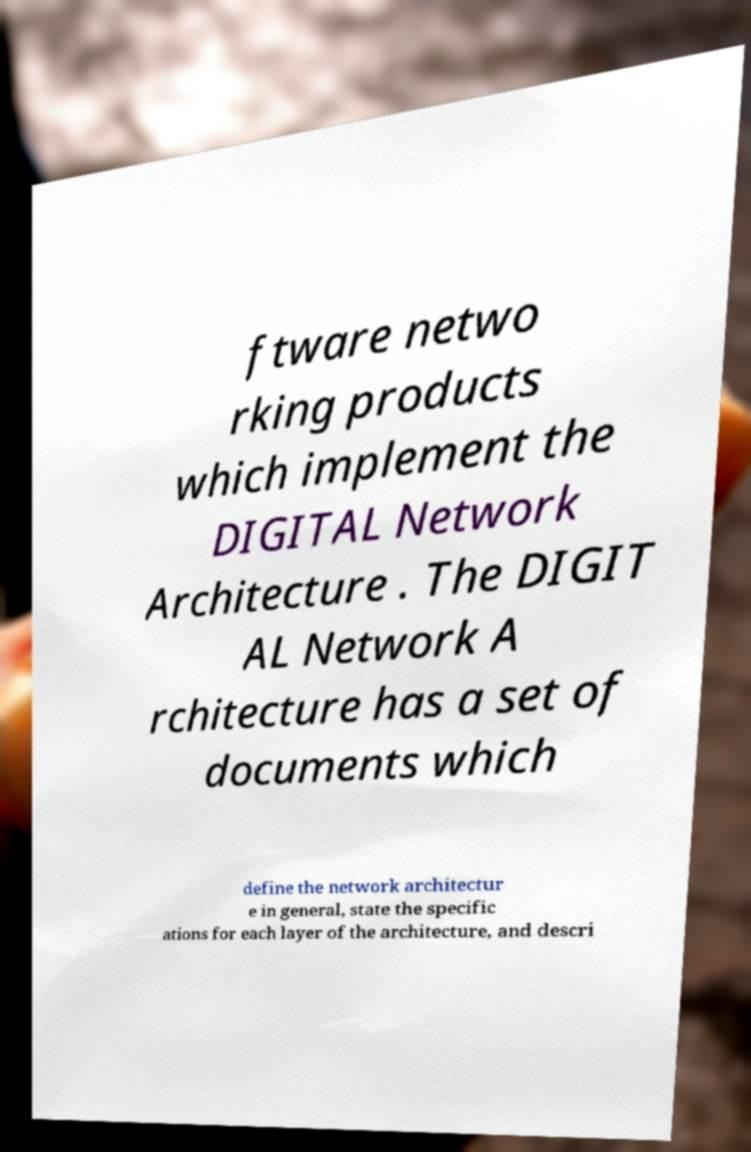Please identify and transcribe the text found in this image. ftware netwo rking products which implement the DIGITAL Network Architecture . The DIGIT AL Network A rchitecture has a set of documents which define the network architectur e in general, state the specific ations for each layer of the architecture, and descri 